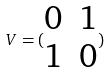<formula> <loc_0><loc_0><loc_500><loc_500>V = ( \begin{matrix} 0 & 1 \\ 1 & 0 \end{matrix} )</formula> 